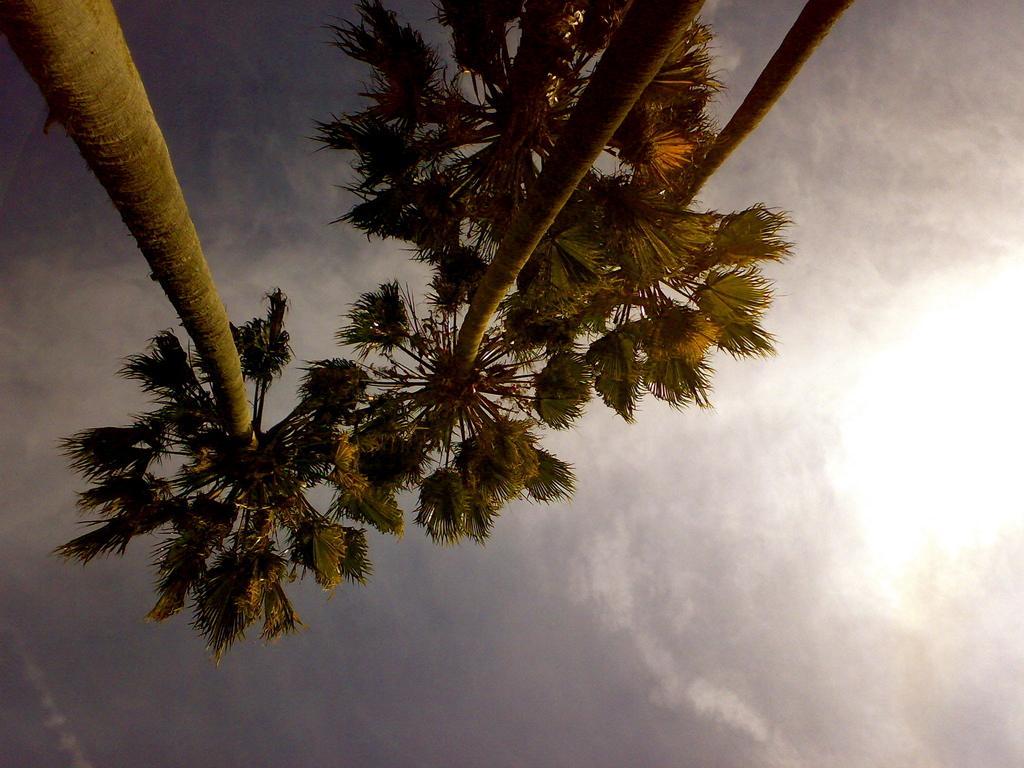Please provide a concise description of this image. In the picture we can see few coconut trees and in the background, we can see the sky with clouds. 